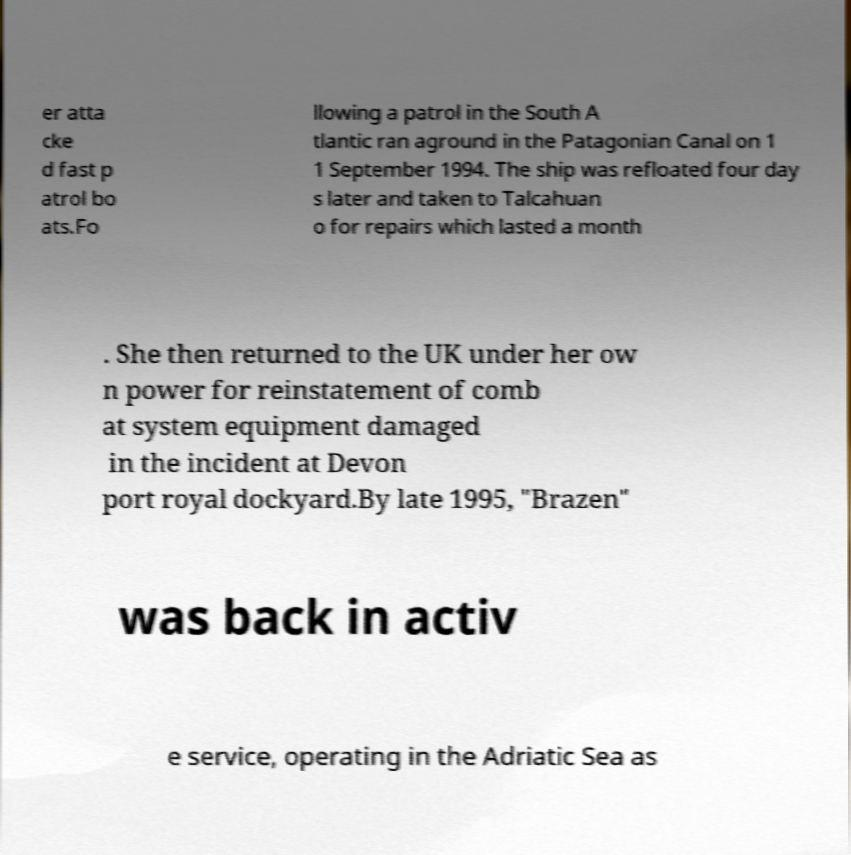What messages or text are displayed in this image? I need them in a readable, typed format. er atta cke d fast p atrol bo ats.Fo llowing a patrol in the South A tlantic ran aground in the Patagonian Canal on 1 1 September 1994. The ship was refloated four day s later and taken to Talcahuan o for repairs which lasted a month . She then returned to the UK under her ow n power for reinstatement of comb at system equipment damaged in the incident at Devon port royal dockyard.By late 1995, "Brazen" was back in activ e service, operating in the Adriatic Sea as 